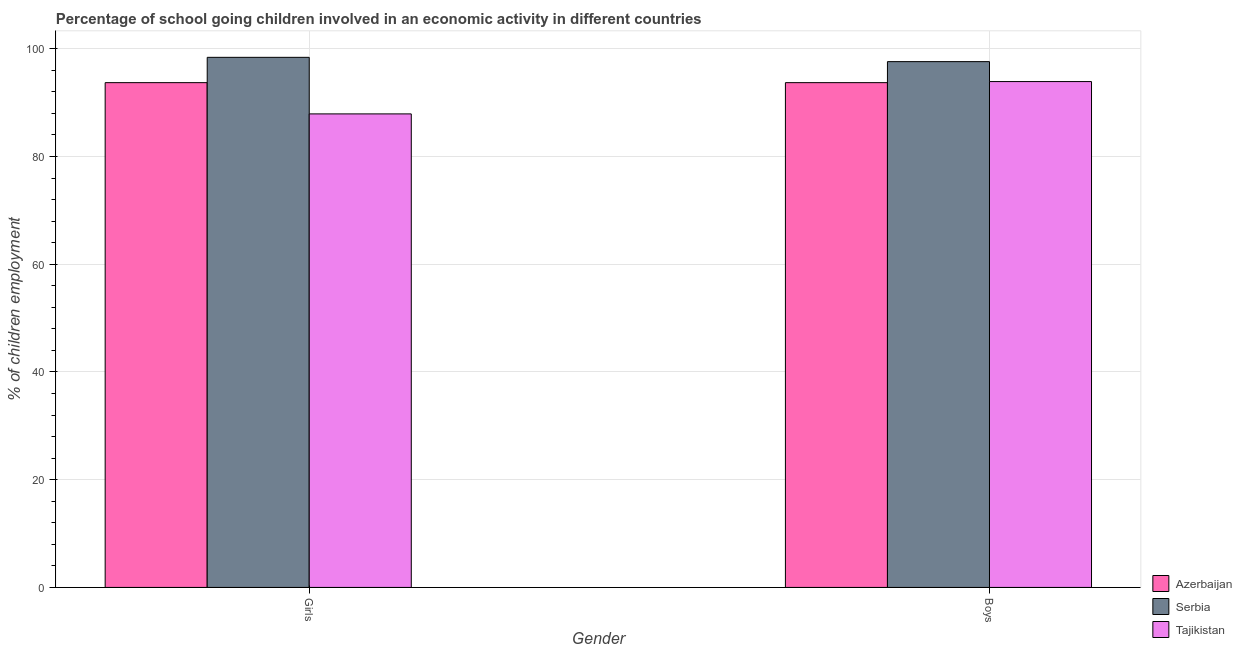How many different coloured bars are there?
Ensure brevity in your answer.  3. Are the number of bars per tick equal to the number of legend labels?
Offer a terse response. Yes. Are the number of bars on each tick of the X-axis equal?
Provide a succinct answer. Yes. How many bars are there on the 2nd tick from the left?
Offer a terse response. 3. How many bars are there on the 2nd tick from the right?
Your answer should be compact. 3. What is the label of the 1st group of bars from the left?
Offer a very short reply. Girls. What is the percentage of school going boys in Serbia?
Your answer should be very brief. 97.6. Across all countries, what is the maximum percentage of school going girls?
Provide a short and direct response. 98.4. Across all countries, what is the minimum percentage of school going girls?
Make the answer very short. 87.9. In which country was the percentage of school going boys maximum?
Ensure brevity in your answer.  Serbia. In which country was the percentage of school going girls minimum?
Your answer should be compact. Tajikistan. What is the total percentage of school going girls in the graph?
Keep it short and to the point. 280. What is the difference between the percentage of school going boys in Azerbaijan and that in Tajikistan?
Offer a very short reply. -0.2. What is the difference between the percentage of school going girls in Azerbaijan and the percentage of school going boys in Serbia?
Your answer should be very brief. -3.9. What is the average percentage of school going boys per country?
Provide a short and direct response. 95.07. What is the ratio of the percentage of school going boys in Serbia to that in Tajikistan?
Offer a very short reply. 1.04. Is the percentage of school going girls in Serbia less than that in Azerbaijan?
Make the answer very short. No. What does the 1st bar from the left in Girls represents?
Make the answer very short. Azerbaijan. What does the 2nd bar from the right in Girls represents?
Your answer should be very brief. Serbia. How many bars are there?
Offer a very short reply. 6. What is the difference between two consecutive major ticks on the Y-axis?
Offer a very short reply. 20. Where does the legend appear in the graph?
Your response must be concise. Bottom right. How many legend labels are there?
Keep it short and to the point. 3. How are the legend labels stacked?
Keep it short and to the point. Vertical. What is the title of the graph?
Your answer should be very brief. Percentage of school going children involved in an economic activity in different countries. What is the label or title of the X-axis?
Provide a succinct answer. Gender. What is the label or title of the Y-axis?
Ensure brevity in your answer.  % of children employment. What is the % of children employment of Azerbaijan in Girls?
Your response must be concise. 93.7. What is the % of children employment of Serbia in Girls?
Provide a succinct answer. 98.4. What is the % of children employment in Tajikistan in Girls?
Make the answer very short. 87.9. What is the % of children employment of Azerbaijan in Boys?
Provide a short and direct response. 93.7. What is the % of children employment in Serbia in Boys?
Provide a short and direct response. 97.6. What is the % of children employment of Tajikistan in Boys?
Your answer should be very brief. 93.9. Across all Gender, what is the maximum % of children employment of Azerbaijan?
Ensure brevity in your answer.  93.7. Across all Gender, what is the maximum % of children employment of Serbia?
Your response must be concise. 98.4. Across all Gender, what is the maximum % of children employment of Tajikistan?
Your response must be concise. 93.9. Across all Gender, what is the minimum % of children employment in Azerbaijan?
Provide a short and direct response. 93.7. Across all Gender, what is the minimum % of children employment of Serbia?
Provide a short and direct response. 97.6. Across all Gender, what is the minimum % of children employment in Tajikistan?
Offer a terse response. 87.9. What is the total % of children employment in Azerbaijan in the graph?
Offer a terse response. 187.4. What is the total % of children employment of Serbia in the graph?
Make the answer very short. 196. What is the total % of children employment of Tajikistan in the graph?
Keep it short and to the point. 181.8. What is the difference between the % of children employment in Tajikistan in Girls and that in Boys?
Offer a very short reply. -6. What is the difference between the % of children employment of Azerbaijan in Girls and the % of children employment of Serbia in Boys?
Your response must be concise. -3.9. What is the difference between the % of children employment of Serbia in Girls and the % of children employment of Tajikistan in Boys?
Your response must be concise. 4.5. What is the average % of children employment of Azerbaijan per Gender?
Offer a very short reply. 93.7. What is the average % of children employment in Tajikistan per Gender?
Provide a short and direct response. 90.9. What is the difference between the % of children employment in Azerbaijan and % of children employment in Serbia in Girls?
Make the answer very short. -4.7. What is the difference between the % of children employment of Serbia and % of children employment of Tajikistan in Girls?
Offer a very short reply. 10.5. What is the difference between the % of children employment in Azerbaijan and % of children employment in Serbia in Boys?
Your answer should be very brief. -3.9. What is the difference between the % of children employment in Azerbaijan and % of children employment in Tajikistan in Boys?
Your answer should be very brief. -0.2. What is the ratio of the % of children employment of Azerbaijan in Girls to that in Boys?
Your answer should be very brief. 1. What is the ratio of the % of children employment in Serbia in Girls to that in Boys?
Offer a very short reply. 1.01. What is the ratio of the % of children employment of Tajikistan in Girls to that in Boys?
Offer a terse response. 0.94. What is the difference between the highest and the second highest % of children employment in Azerbaijan?
Provide a short and direct response. 0. What is the difference between the highest and the second highest % of children employment in Serbia?
Your response must be concise. 0.8. What is the difference between the highest and the second highest % of children employment in Tajikistan?
Offer a very short reply. 6. What is the difference between the highest and the lowest % of children employment in Tajikistan?
Offer a terse response. 6. 